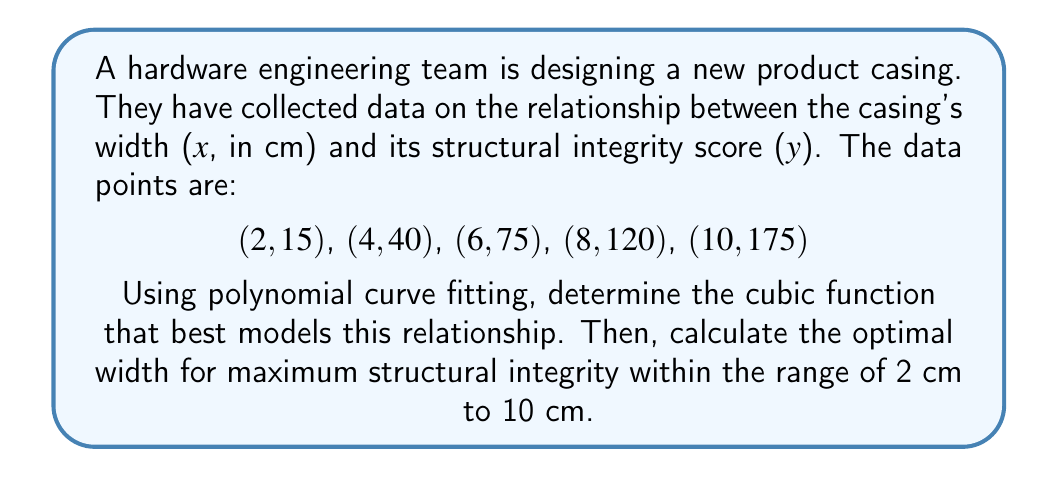Can you solve this math problem? 1) For a cubic function $y = ax^3 + bx^2 + cx + d$, we need to solve for a, b, c, and d.

2) Using a computer algebra system or matrix operations, we can solve the system of equations:

   $$\begin{bmatrix}
   2^3 & 2^2 & 2 & 1 \\
   4^3 & 4^2 & 4 & 1 \\
   6^3 & 6^2 & 6 & 1 \\
   8^3 & 8^2 & 8 & 1 \\
   10^3 & 10^2 & 10 & 1
   \end{bmatrix}
   \begin{bmatrix}
   a \\ b \\ c \\ d
   \end{bmatrix} =
   \begin{bmatrix}
   15 \\ 40 \\ 75 \\ 120 \\ 175
   \end{bmatrix}$$

3) Solving this system gives us:
   $a \approx 0.1042, b \approx -0.4167, c \approx 5.3125, d \approx -5$

4) So, our cubic function is:
   $y = 0.1042x^3 - 0.4167x^2 + 5.3125x - 5$

5) To find the maximum, we differentiate and set to zero:
   $\frac{dy}{dx} = 0.3126x^2 - 0.8334x + 5.3125 = 0$

6) Solving this quadratic equation:
   $x \approx 8.17$ or $x \approx -5.51$

7) Since -5.51 is outside our range, and 8.17 is within 2 to 10, 8.17 cm is our optimal width.
Answer: 8.17 cm 